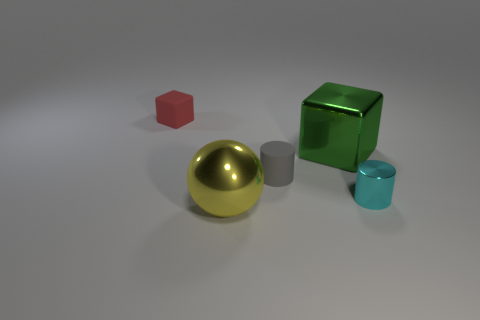What number of objects are either big things or large gray balls?
Your response must be concise. 2. How many rubber things are the same color as the large metallic block?
Give a very brief answer. 0. There is a rubber thing that is the same size as the matte block; what is its shape?
Ensure brevity in your answer.  Cylinder. Are there any other big objects that have the same shape as the green thing?
Make the answer very short. No. How many tiny cyan things have the same material as the red thing?
Make the answer very short. 0. Does the block in front of the red block have the same material as the large ball?
Your answer should be very brief. Yes. Are there more yellow things that are behind the yellow sphere than metallic cylinders that are in front of the cyan cylinder?
Make the answer very short. No. What is the material of the cyan thing that is the same size as the matte cylinder?
Ensure brevity in your answer.  Metal. How many other things are the same material as the tiny red block?
Ensure brevity in your answer.  1. There is a metal thing behind the tiny cyan shiny thing; is it the same shape as the big object that is in front of the tiny metallic object?
Offer a terse response. No. 